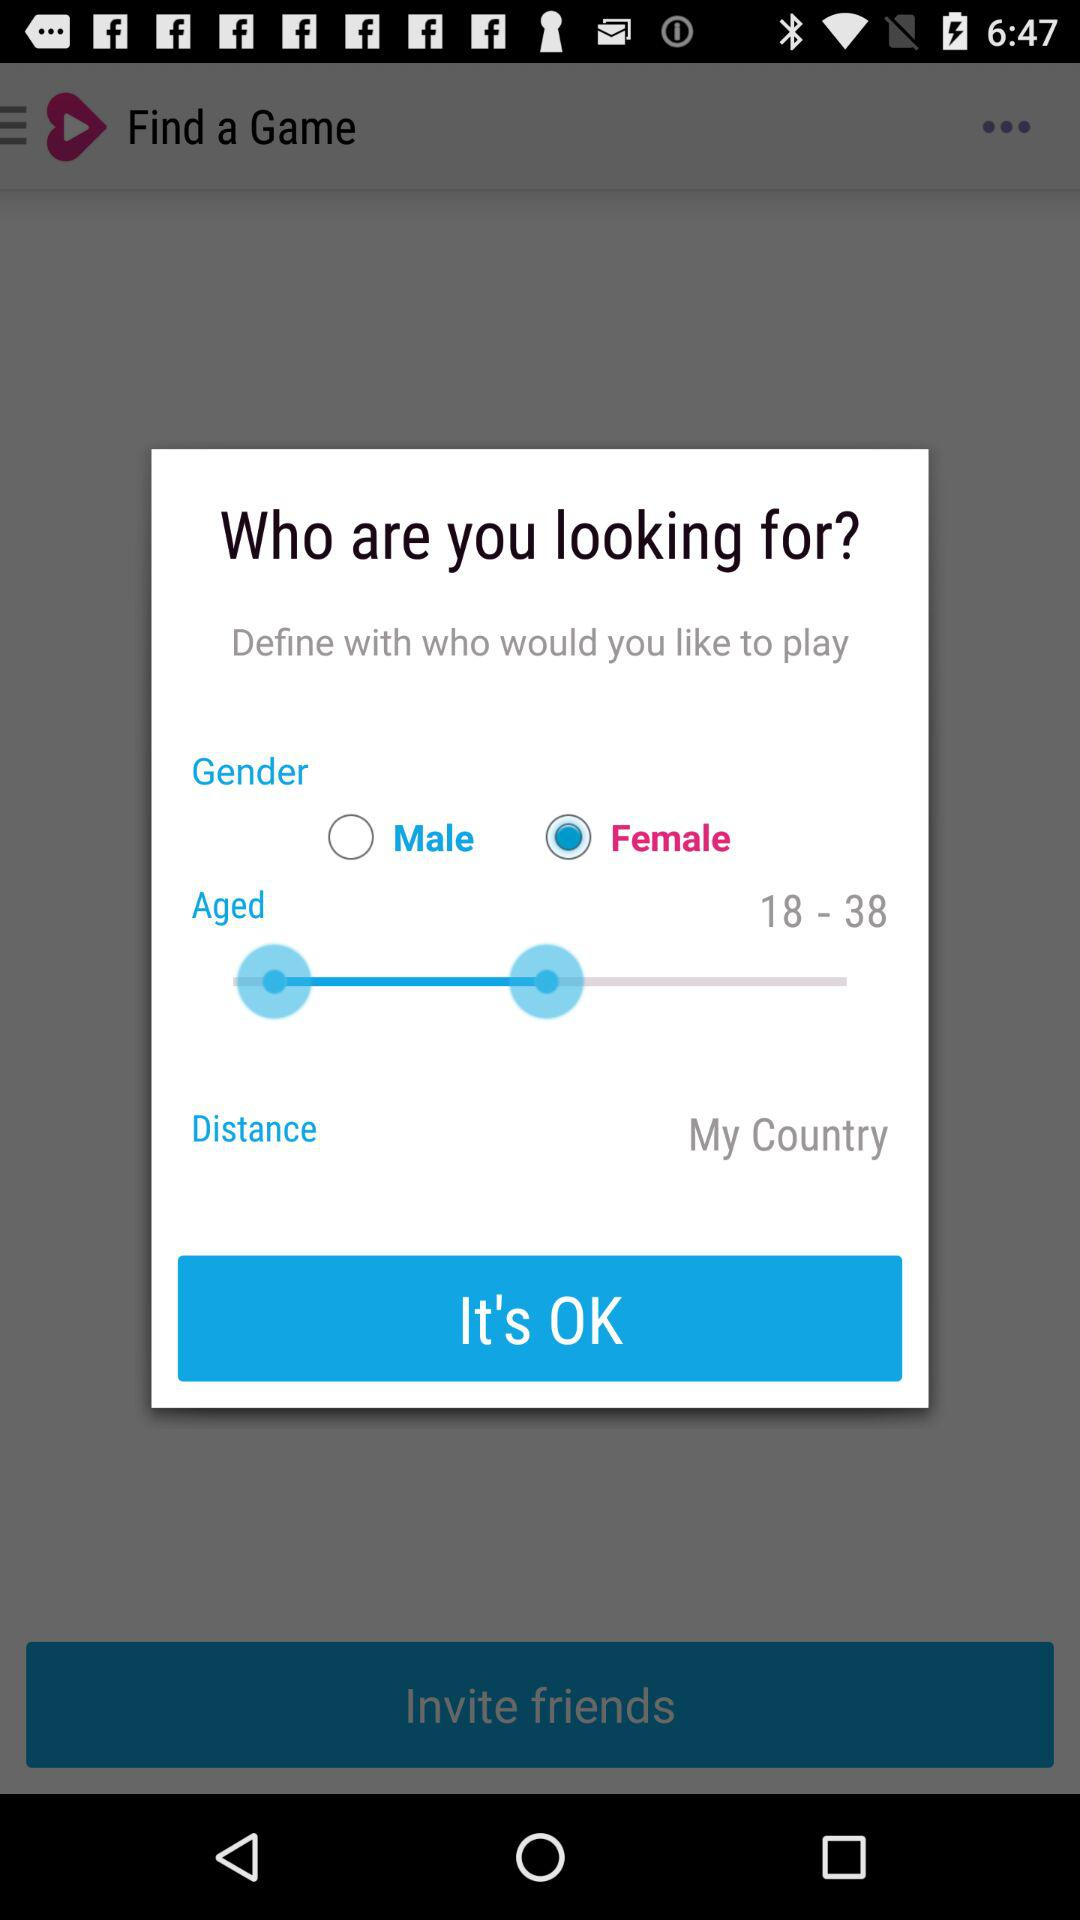What is the selected gender? The selected gender is female. 